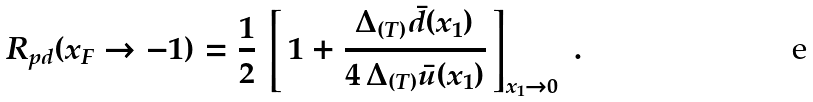Convert formula to latex. <formula><loc_0><loc_0><loc_500><loc_500>R _ { p d } ( x _ { F } \rightarrow - 1 ) = \frac { 1 } { 2 } \, \left [ \, 1 + \frac { \Delta _ { ( T ) } \bar { d } ( x _ { 1 } ) } { 4 \, \Delta _ { ( T ) } \bar { u } ( x _ { 1 } ) } \, \right ] _ { x _ { 1 } \rightarrow 0 } \ .</formula> 